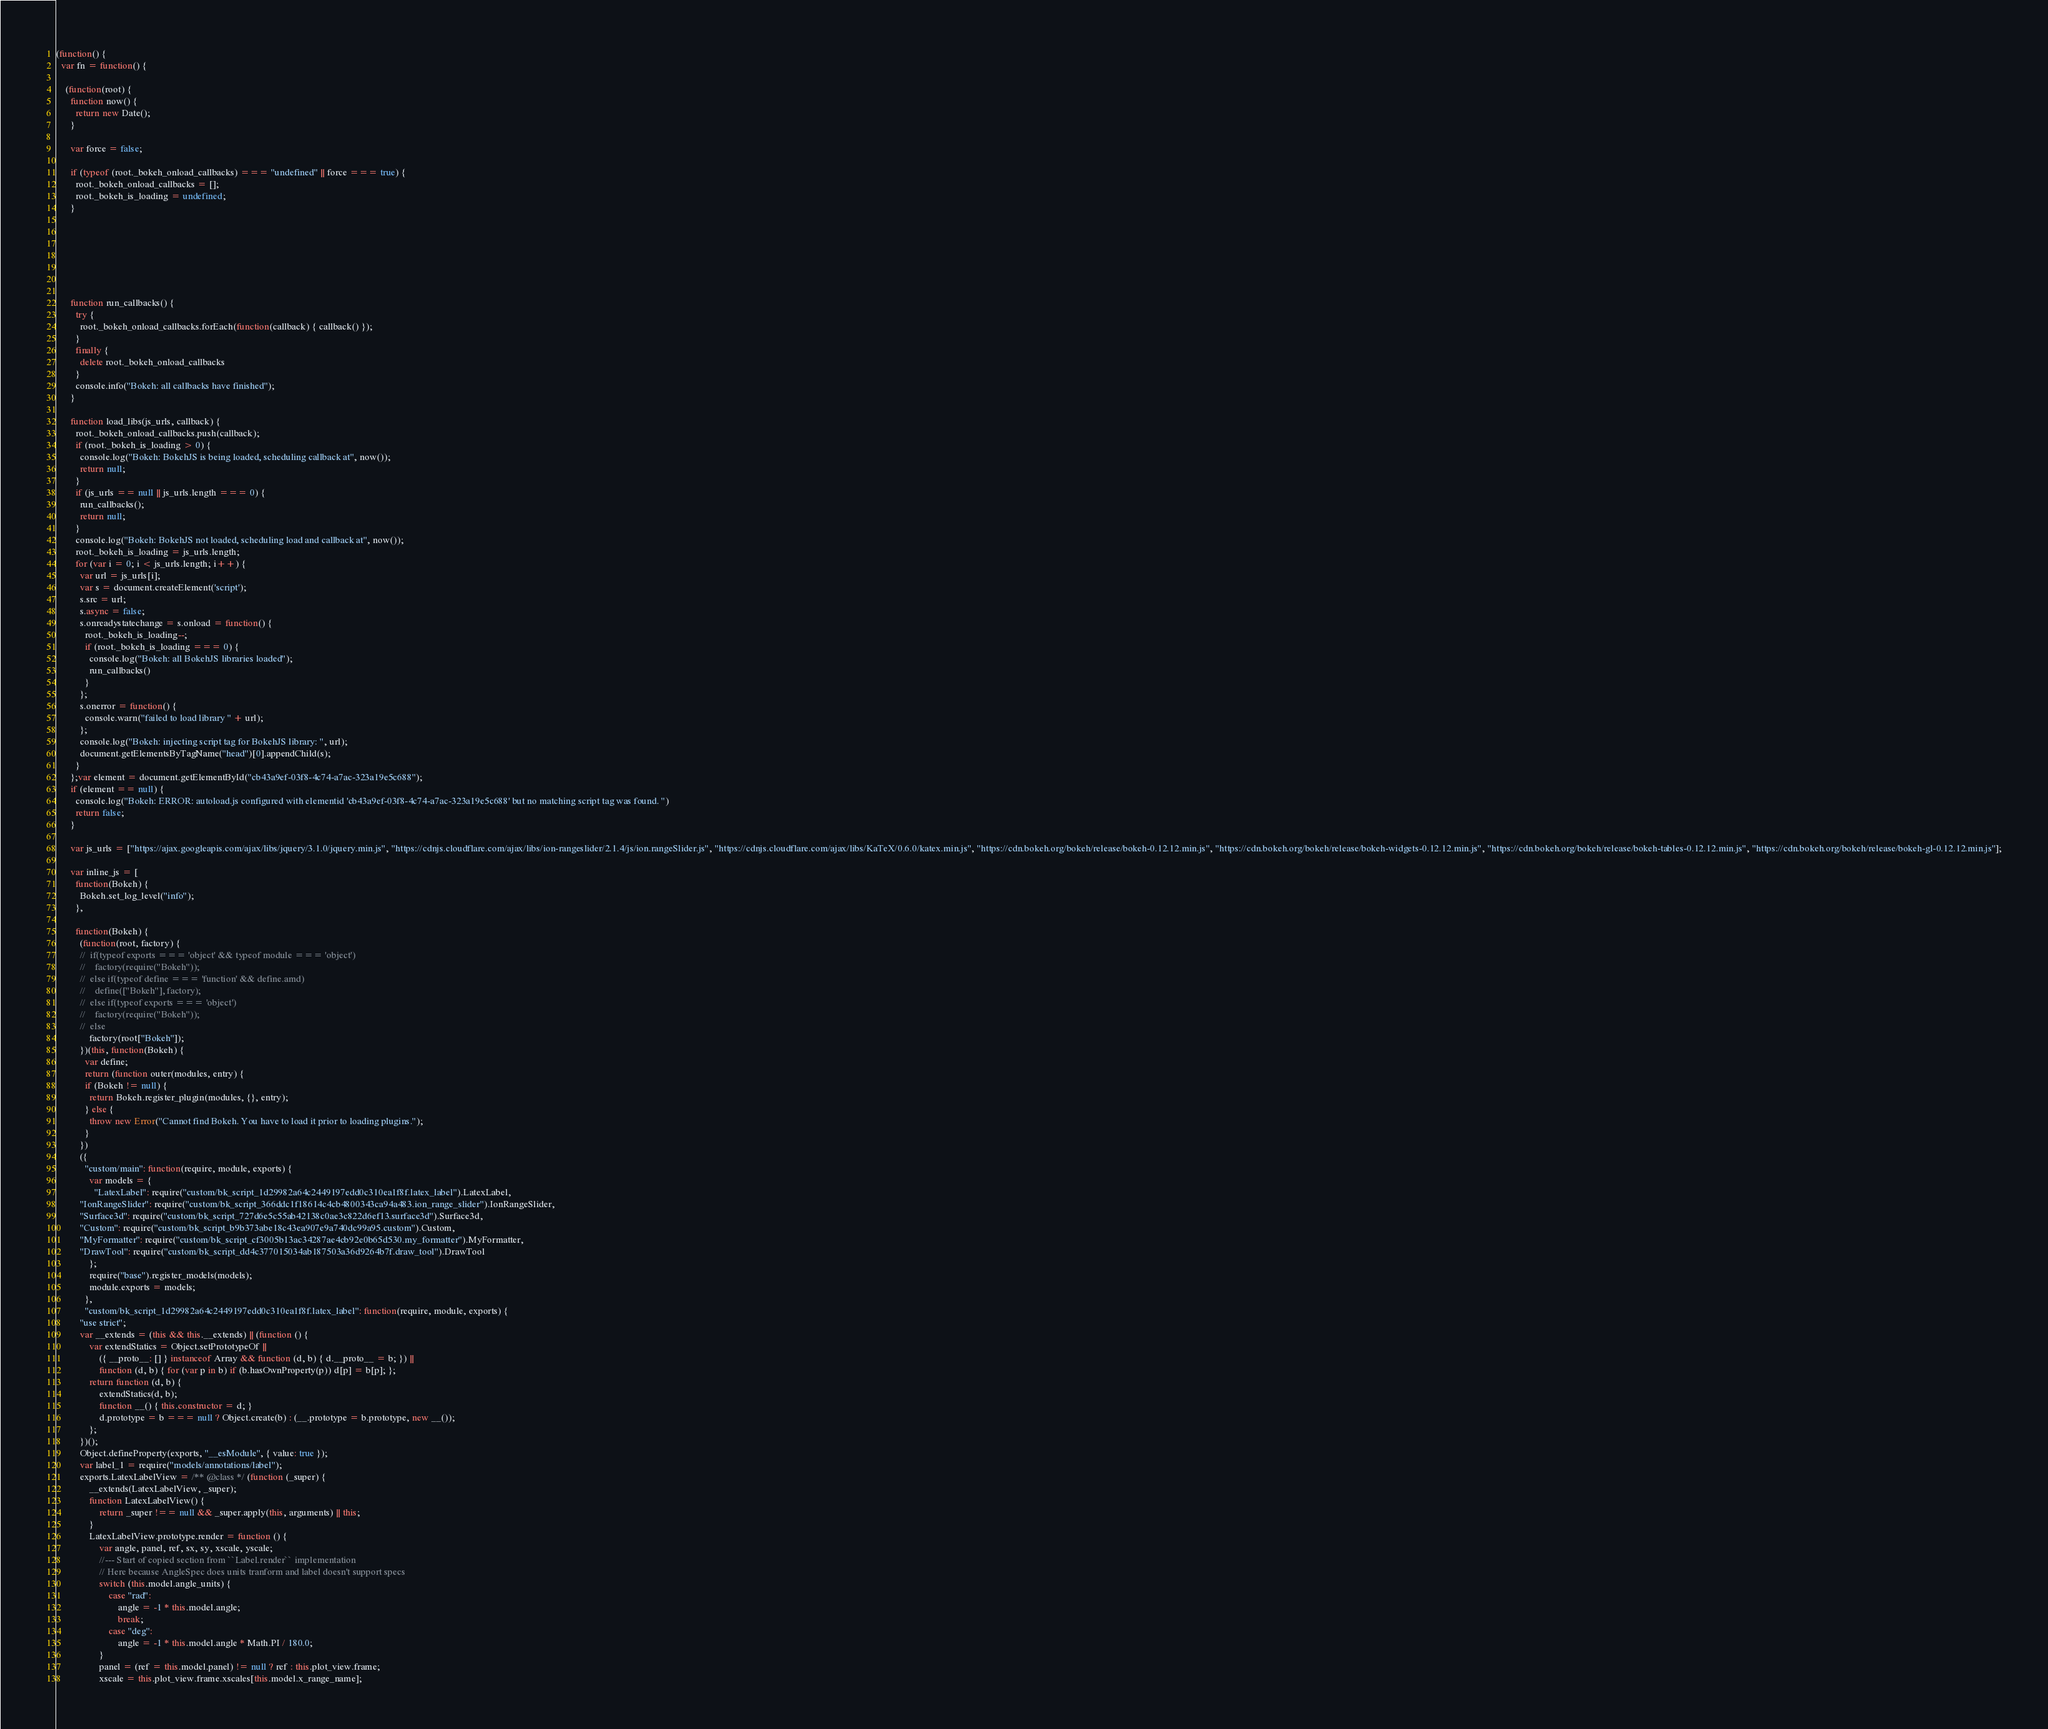Convert code to text. <code><loc_0><loc_0><loc_500><loc_500><_JavaScript_>(function() {
  var fn = function() {
    
    (function(root) {
      function now() {
        return new Date();
      }
    
      var force = false;
    
      if (typeof (root._bokeh_onload_callbacks) === "undefined" || force === true) {
        root._bokeh_onload_callbacks = [];
        root._bokeh_is_loading = undefined;
      }
    
      
      
    
      
      
    
      function run_callbacks() {
        try {
          root._bokeh_onload_callbacks.forEach(function(callback) { callback() });
        }
        finally {
          delete root._bokeh_onload_callbacks
        }
        console.info("Bokeh: all callbacks have finished");
      }
    
      function load_libs(js_urls, callback) {
        root._bokeh_onload_callbacks.push(callback);
        if (root._bokeh_is_loading > 0) {
          console.log("Bokeh: BokehJS is being loaded, scheduling callback at", now());
          return null;
        }
        if (js_urls == null || js_urls.length === 0) {
          run_callbacks();
          return null;
        }
        console.log("Bokeh: BokehJS not loaded, scheduling load and callback at", now());
        root._bokeh_is_loading = js_urls.length;
        for (var i = 0; i < js_urls.length; i++) {
          var url = js_urls[i];
          var s = document.createElement('script');
          s.src = url;
          s.async = false;
          s.onreadystatechange = s.onload = function() {
            root._bokeh_is_loading--;
            if (root._bokeh_is_loading === 0) {
              console.log("Bokeh: all BokehJS libraries loaded");
              run_callbacks()
            }
          };
          s.onerror = function() {
            console.warn("failed to load library " + url);
          };
          console.log("Bokeh: injecting script tag for BokehJS library: ", url);
          document.getElementsByTagName("head")[0].appendChild(s);
        }
      };var element = document.getElementById("cb43a9ef-03f8-4c74-a7ac-323a19e5c688");
      if (element == null) {
        console.log("Bokeh: ERROR: autoload.js configured with elementid 'cb43a9ef-03f8-4c74-a7ac-323a19e5c688' but no matching script tag was found. ")
        return false;
      }
    
      var js_urls = ["https://ajax.googleapis.com/ajax/libs/jquery/3.1.0/jquery.min.js", "https://cdnjs.cloudflare.com/ajax/libs/ion-rangeslider/2.1.4/js/ion.rangeSlider.js", "https://cdnjs.cloudflare.com/ajax/libs/KaTeX/0.6.0/katex.min.js", "https://cdn.bokeh.org/bokeh/release/bokeh-0.12.12.min.js", "https://cdn.bokeh.org/bokeh/release/bokeh-widgets-0.12.12.min.js", "https://cdn.bokeh.org/bokeh/release/bokeh-tables-0.12.12.min.js", "https://cdn.bokeh.org/bokeh/release/bokeh-gl-0.12.12.min.js"];
    
      var inline_js = [
        function(Bokeh) {
          Bokeh.set_log_level("info");
        },
        
        function(Bokeh) {
          (function(root, factory) {
          //  if(typeof exports === 'object' && typeof module === 'object')
          //    factory(require("Bokeh"));
          //  else if(typeof define === 'function' && define.amd)
          //    define(["Bokeh"], factory);
          //  else if(typeof exports === 'object')
          //    factory(require("Bokeh"));
          //  else
              factory(root["Bokeh"]);
          })(this, function(Bokeh) {
            var define;
            return (function outer(modules, entry) {
            if (Bokeh != null) {
              return Bokeh.register_plugin(modules, {}, entry);
            } else {
              throw new Error("Cannot find Bokeh. You have to load it prior to loading plugins.");
            }
          })
          ({
            "custom/main": function(require, module, exports) {
              var models = {
                "LatexLabel": require("custom/bk_script_1d29982a64c2449197edd0c310ea1f8f.latex_label").LatexLabel,
          "IonRangeSlider": require("custom/bk_script_366ddc1f18614c4cb4800343ca94a483.ion_range_slider").IonRangeSlider,
          "Surface3d": require("custom/bk_script_727d6e5c55ab42138c0ae3c822d6ef13.surface3d").Surface3d,
          "Custom": require("custom/bk_script_b9b373abe18c43ea907e9a740dc99a95.custom").Custom,
          "MyFormatter": require("custom/bk_script_cf3005b13ac34287ae4cb92e0b65d530.my_formatter").MyFormatter,
          "DrawTool": require("custom/bk_script_dd4c377015034ab187503a36d9264b7f.draw_tool").DrawTool
              };
              require("base").register_models(models);
              module.exports = models;
            },
            "custom/bk_script_1d29982a64c2449197edd0c310ea1f8f.latex_label": function(require, module, exports) {
          "use strict";
          var __extends = (this && this.__extends) || (function () {
              var extendStatics = Object.setPrototypeOf ||
                  ({ __proto__: [] } instanceof Array && function (d, b) { d.__proto__ = b; }) ||
                  function (d, b) { for (var p in b) if (b.hasOwnProperty(p)) d[p] = b[p]; };
              return function (d, b) {
                  extendStatics(d, b);
                  function __() { this.constructor = d; }
                  d.prototype = b === null ? Object.create(b) : (__.prototype = b.prototype, new __());
              };
          })();
          Object.defineProperty(exports, "__esModule", { value: true });
          var label_1 = require("models/annotations/label");
          exports.LatexLabelView = /** @class */ (function (_super) {
              __extends(LatexLabelView, _super);
              function LatexLabelView() {
                  return _super !== null && _super.apply(this, arguments) || this;
              }
              LatexLabelView.prototype.render = function () {
                  var angle, panel, ref, sx, sy, xscale, yscale;
                  //--- Start of copied section from ``Label.render`` implementation
                  // Here because AngleSpec does units tranform and label doesn't support specs
                  switch (this.model.angle_units) {
                      case "rad":
                          angle = -1 * this.model.angle;
                          break;
                      case "deg":
                          angle = -1 * this.model.angle * Math.PI / 180.0;
                  }
                  panel = (ref = this.model.panel) != null ? ref : this.plot_view.frame;
                  xscale = this.plot_view.frame.xscales[this.model.x_range_name];</code> 